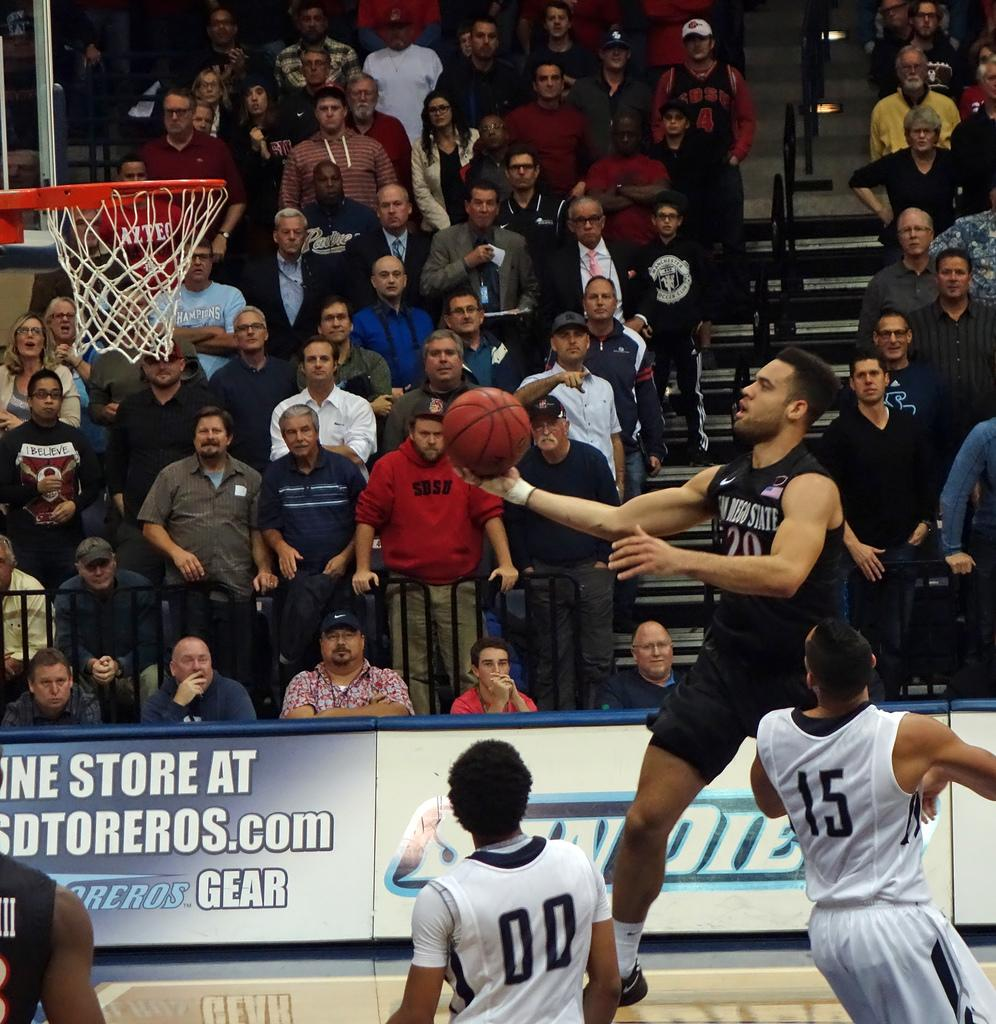<image>
Share a concise interpretation of the image provided. Basketball game with sign on seating area facing court saying online store at USDTorero Stores.com Tereros Gear 